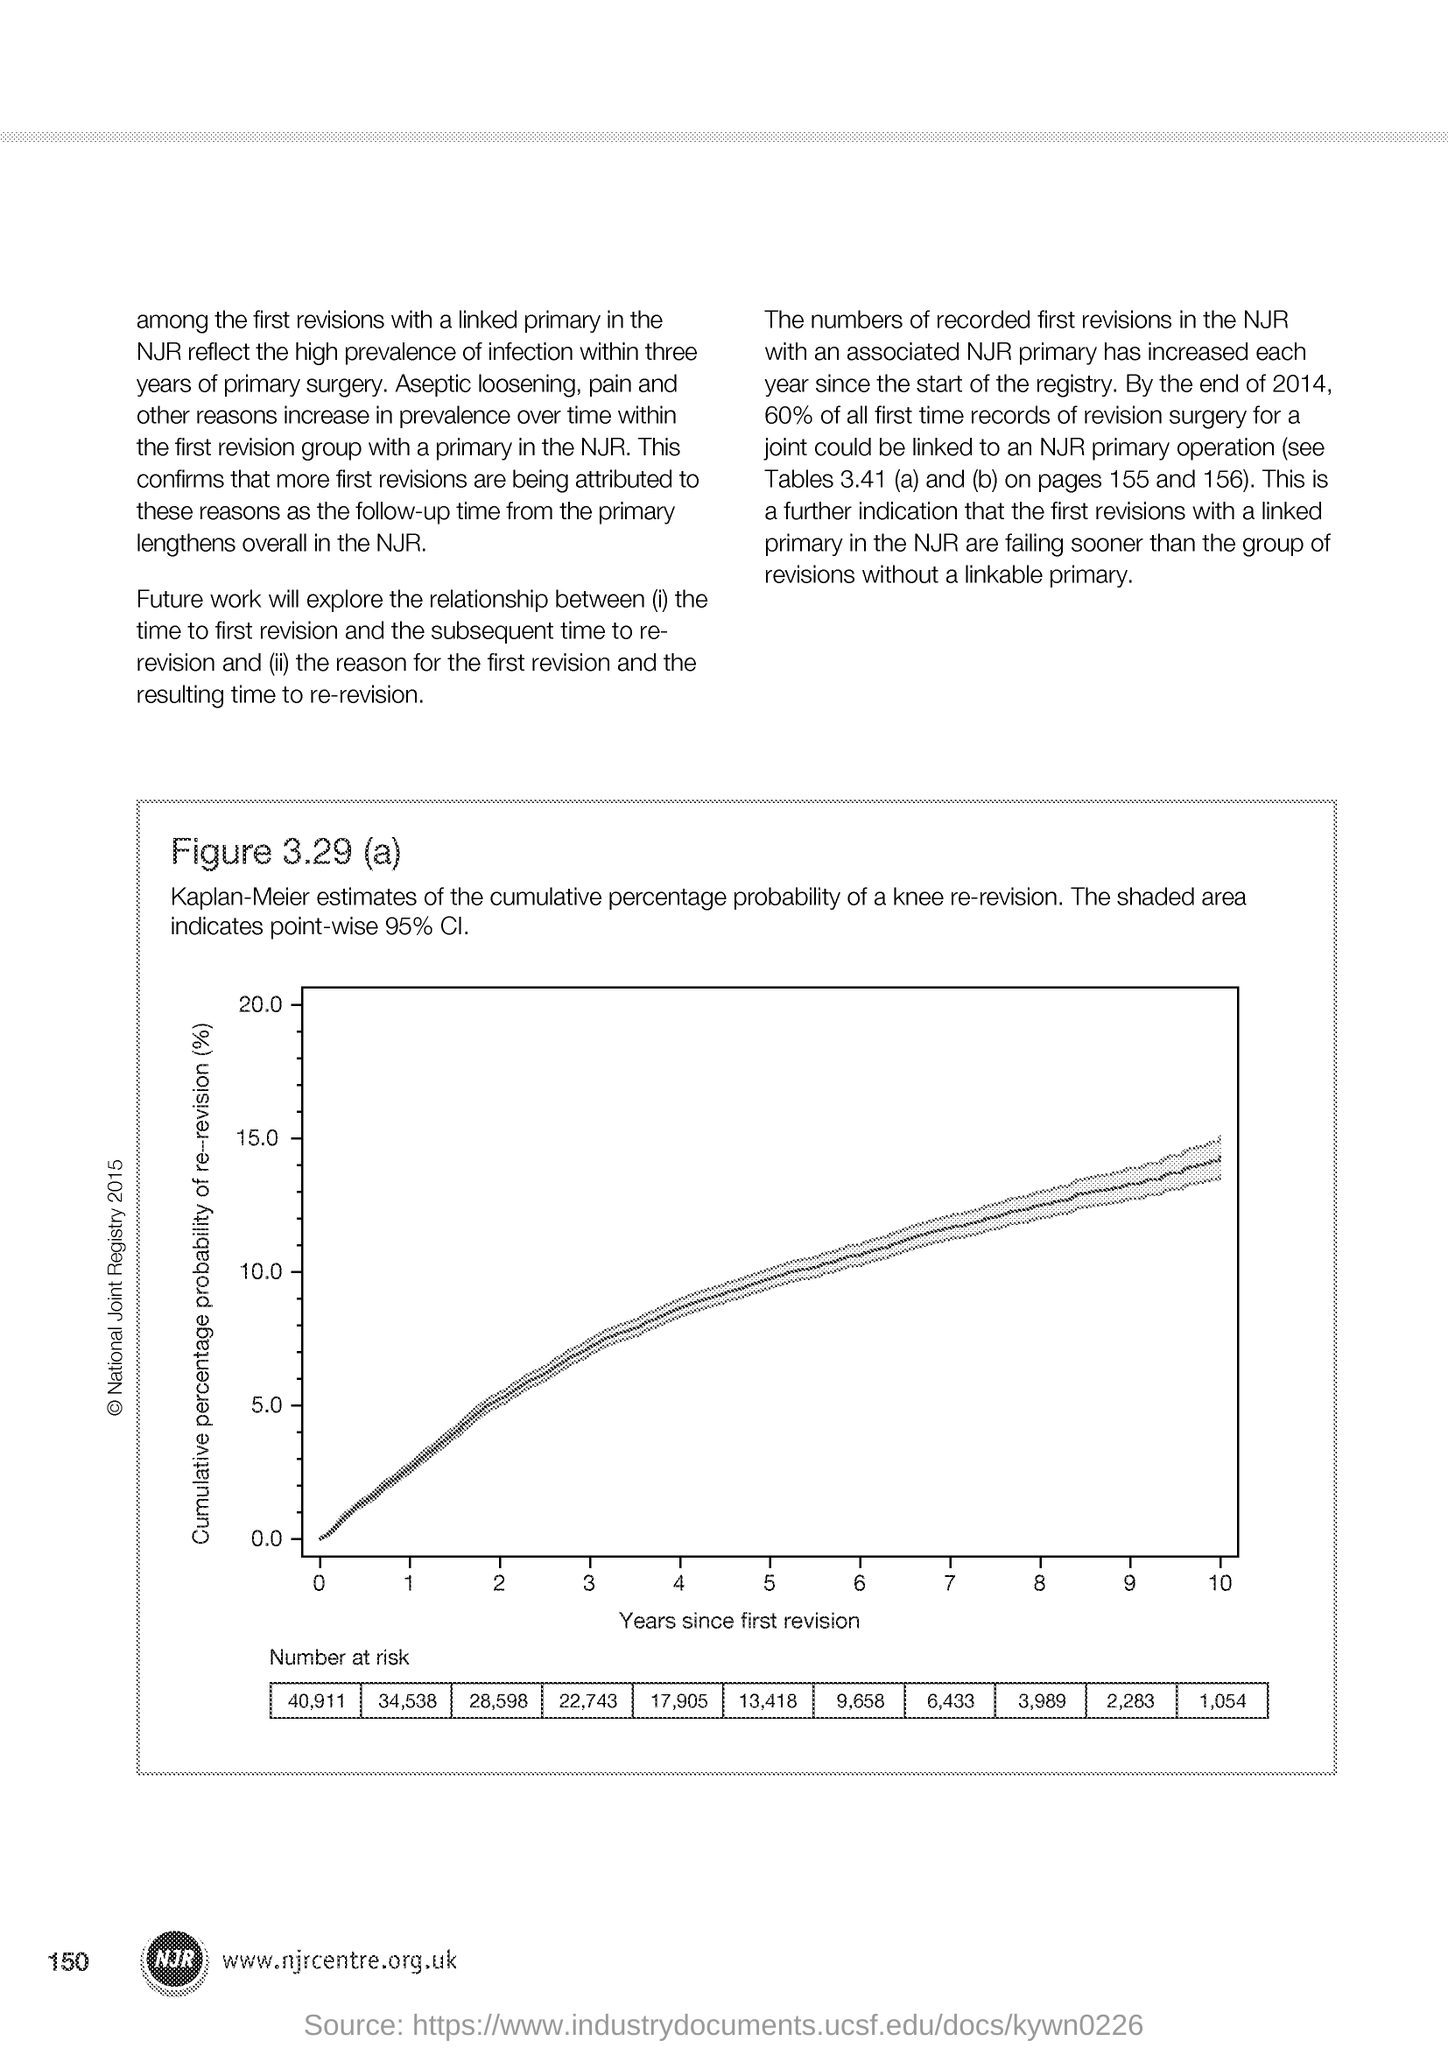What is the Page Number?
Ensure brevity in your answer.  150. What is plotted in the x-axis?
Offer a terse response. Years since first revision. 